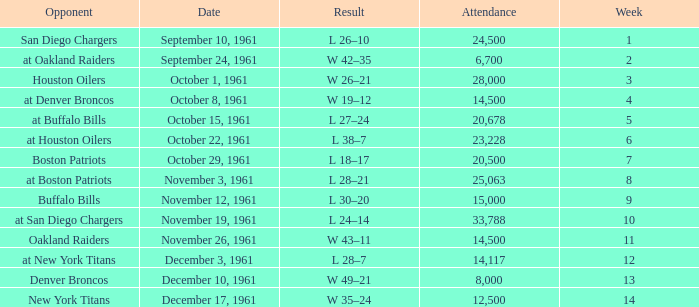What is the low attendance rate against buffalo bills? 15000.0. 